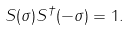Convert formula to latex. <formula><loc_0><loc_0><loc_500><loc_500>S ( \sigma ) S ^ { \dag } ( - \sigma ) = 1 .</formula> 